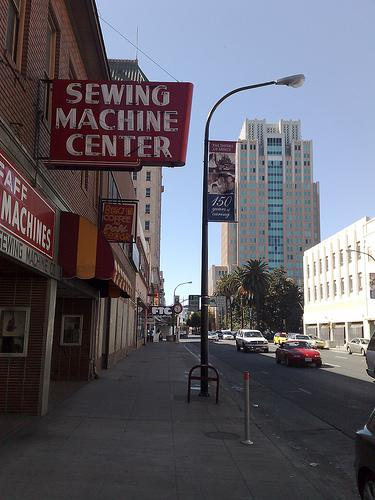Question: what does the large sign say?
Choices:
A. Stop.
B. Sewing machine center.
C. No trespassing.
D. Left Turn Only.
Answer with the letter. Answer: B Question: what color is the tall building?
Choices:
A. Silver.
B. Black.
C. White.
D. Grey.
Answer with the letter. Answer: C Question: when was the photo taken?
Choices:
A. Day.
B. Dusk.
C. Morning.
D. Dawn.
Answer with the letter. Answer: C 